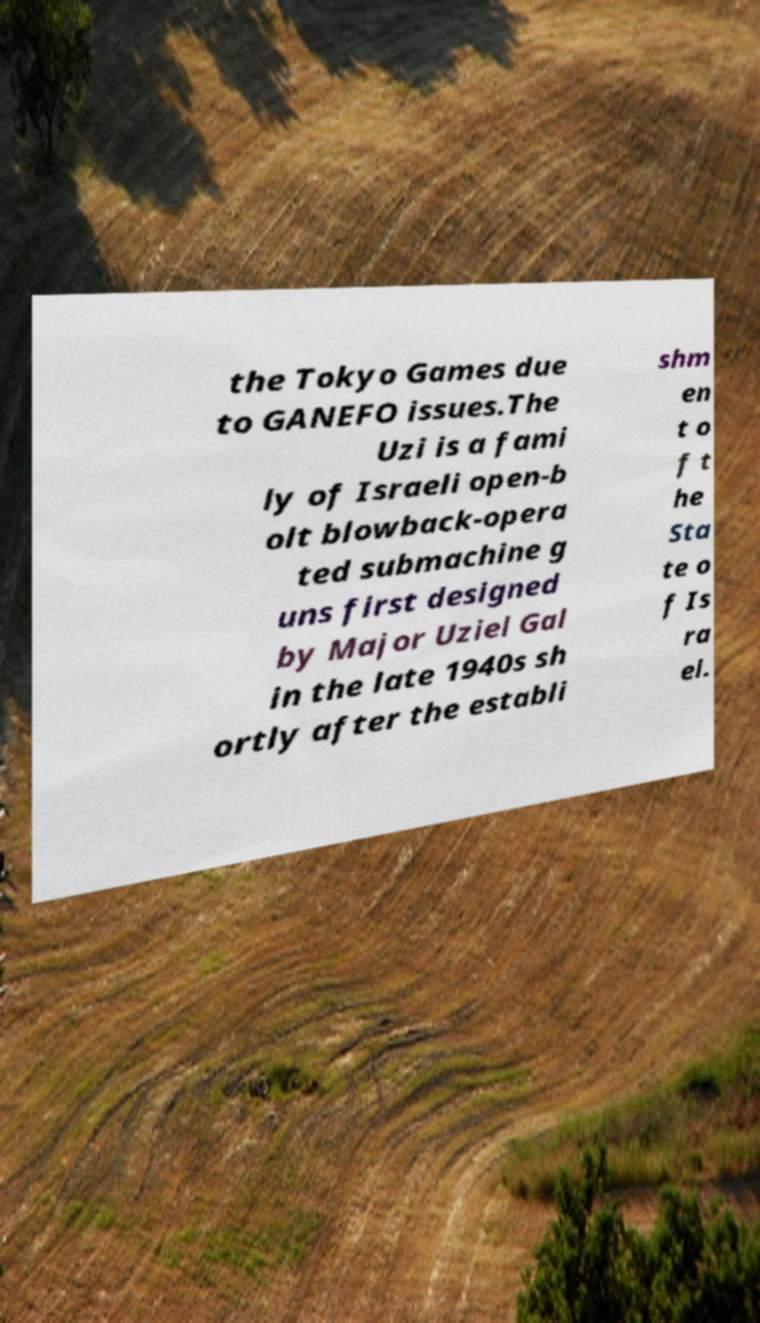Please read and relay the text visible in this image. What does it say? the Tokyo Games due to GANEFO issues.The Uzi is a fami ly of Israeli open-b olt blowback-opera ted submachine g uns first designed by Major Uziel Gal in the late 1940s sh ortly after the establi shm en t o f t he Sta te o f Is ra el. 